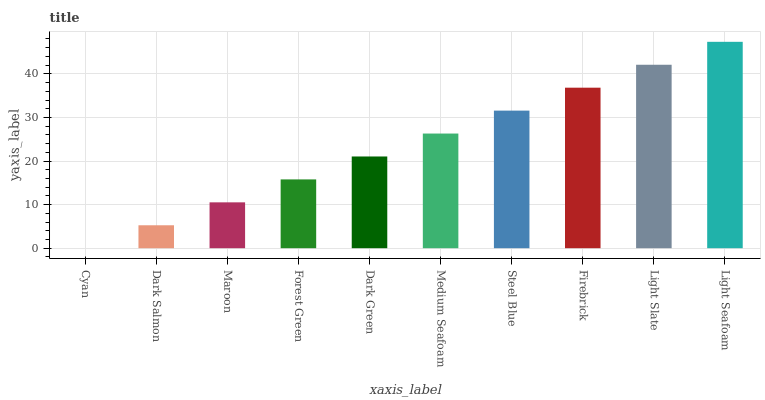Is Cyan the minimum?
Answer yes or no. Yes. Is Light Seafoam the maximum?
Answer yes or no. Yes. Is Dark Salmon the minimum?
Answer yes or no. No. Is Dark Salmon the maximum?
Answer yes or no. No. Is Dark Salmon greater than Cyan?
Answer yes or no. Yes. Is Cyan less than Dark Salmon?
Answer yes or no. Yes. Is Cyan greater than Dark Salmon?
Answer yes or no. No. Is Dark Salmon less than Cyan?
Answer yes or no. No. Is Medium Seafoam the high median?
Answer yes or no. Yes. Is Dark Green the low median?
Answer yes or no. Yes. Is Dark Salmon the high median?
Answer yes or no. No. Is Cyan the low median?
Answer yes or no. No. 